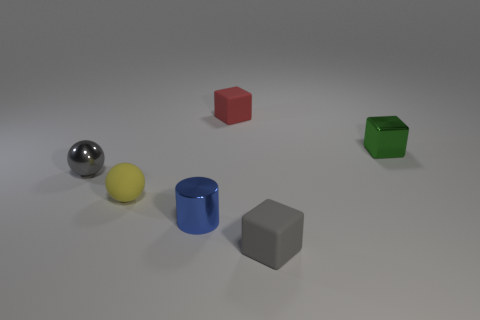Add 3 green cylinders. How many objects exist? 9 Subtract all cylinders. How many objects are left? 5 Subtract 1 gray balls. How many objects are left? 5 Subtract all shiny cylinders. Subtract all small yellow rubber things. How many objects are left? 4 Add 3 small gray things. How many small gray things are left? 5 Add 3 gray things. How many gray things exist? 5 